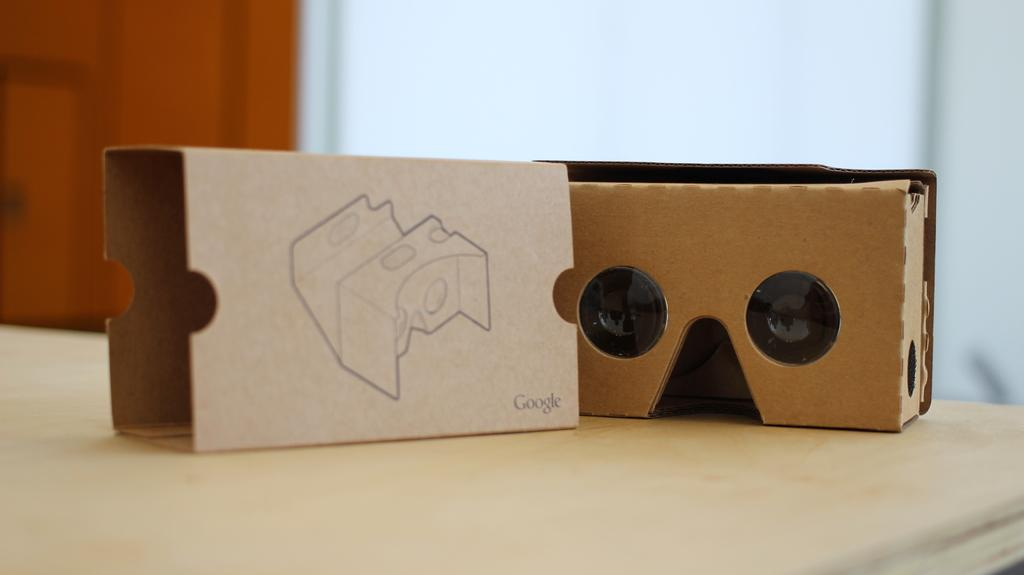What material are the pieces on the table made of? The pieces on the table are made of cardboard. How many properties are visible in the image? There are no properties visible in the image; it only shows cardboard pieces on a table. How many passengers are present in the image? There are no passengers present in the image; it only shows cardboard pieces on a table. 